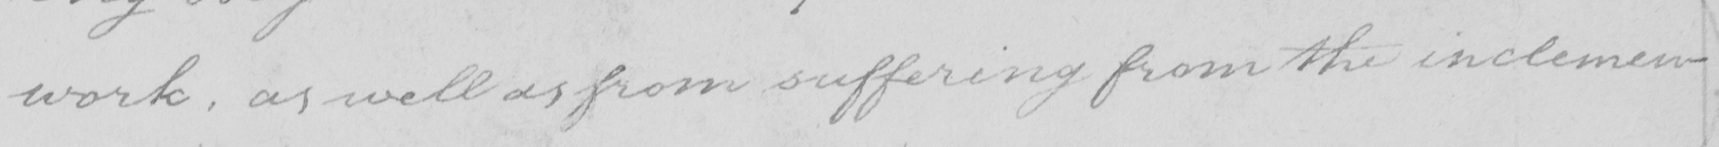Can you tell me what this handwritten text says? work , as well as from suffering from the inclemen- 